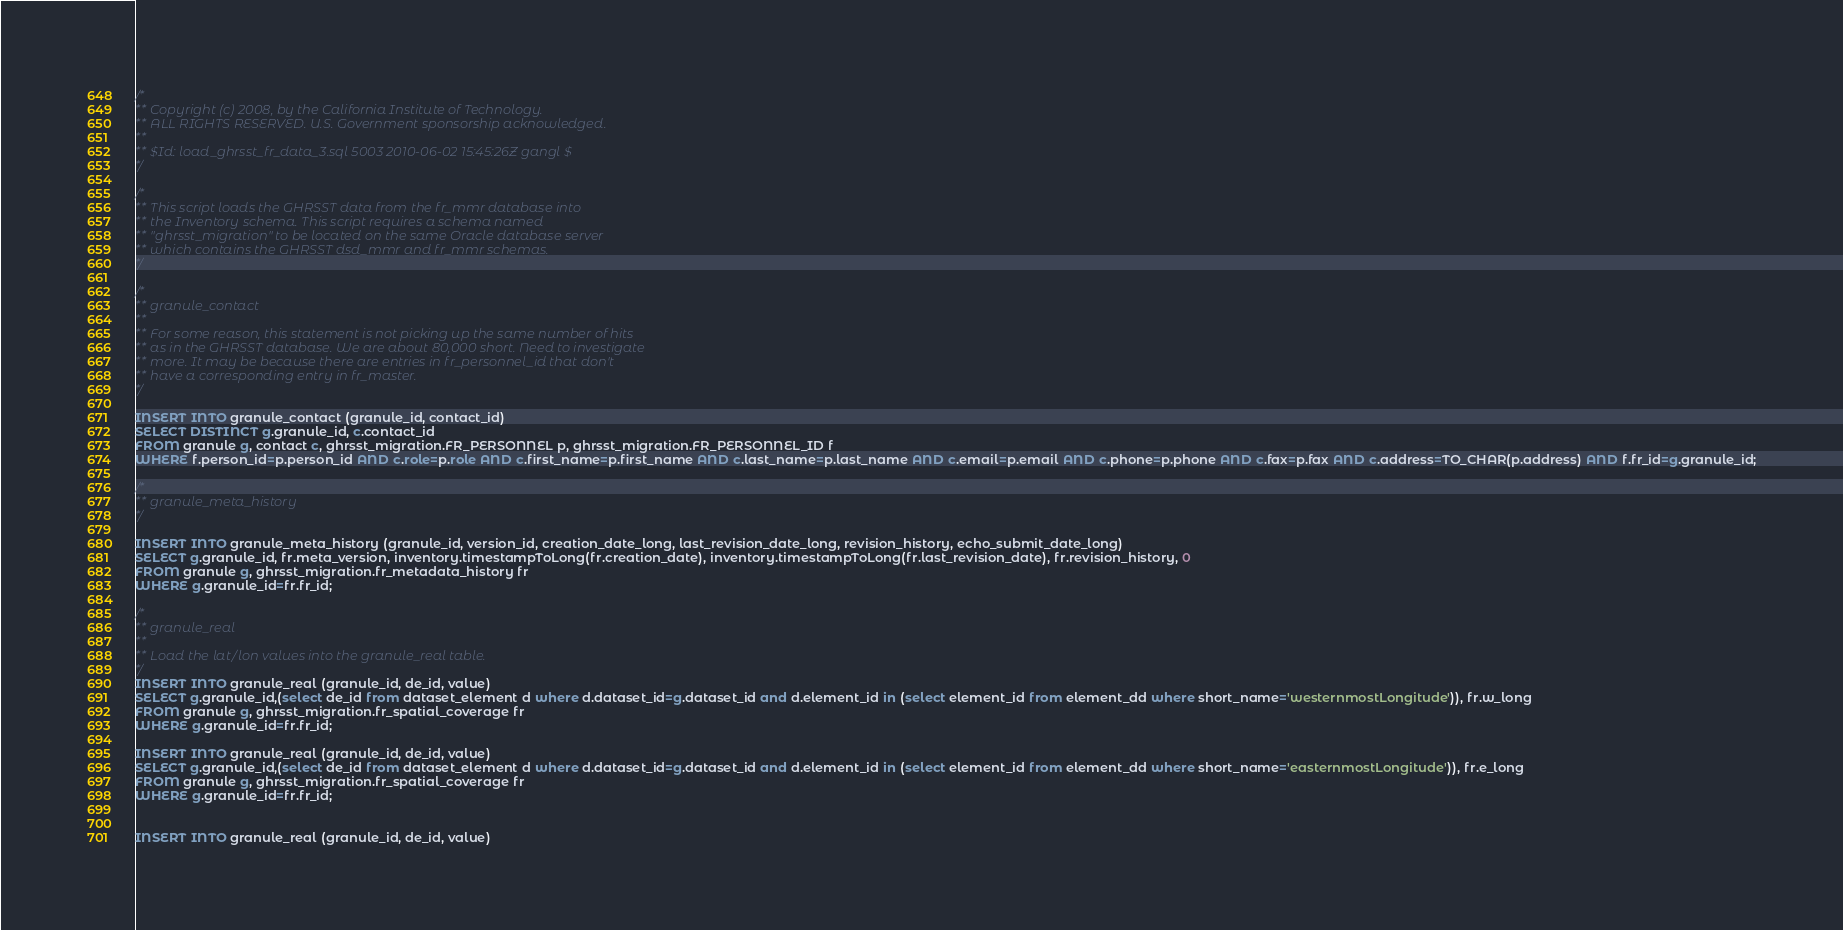<code> <loc_0><loc_0><loc_500><loc_500><_SQL_>/*
** Copyright (c) 2008, by the California Institute of Technology.
** ALL RIGHTS RESERVED. U.S. Government sponsorship acknowledged.
**
** $Id: load_ghrsst_fr_data_3.sql 5003 2010-06-02 15:45:26Z gangl $
*/

/*
** This script loads the GHRSST data from the fr_mmr database into 
** the Inventory schema. This script requires a schema named 
** "ghrsst_migration" to be located on the same Oracle database server 
** which contains the GHRSST dsd_mmr and fr_mmr schemas.
*/

/*
** granule_contact
**
** For some reason, this statement is not picking up the same number of hits 
** as in the GHRSST database. We are about 80,000 short. Need to investigate
** more. It may be because there are entries in fr_personnel_id that don't 
** have a corresponding entry in fr_master.
*/

INSERT INTO granule_contact (granule_id, contact_id)
SELECT DISTINCT g.granule_id, c.contact_id
FROM granule g, contact c, ghrsst_migration.FR_PERSONNEL p, ghrsst_migration.FR_PERSONNEL_ID f
WHERE f.person_id=p.person_id AND c.role=p.role AND c.first_name=p.first_name AND c.last_name=p.last_name AND c.email=p.email AND c.phone=p.phone AND c.fax=p.fax AND c.address=TO_CHAR(p.address) AND f.fr_id=g.granule_id;

/* 
** granule_meta_history
*/

INSERT INTO granule_meta_history (granule_id, version_id, creation_date_long, last_revision_date_long, revision_history, echo_submit_date_long)
SELECT g.granule_id, fr.meta_version, inventory.timestampToLong(fr.creation_date), inventory.timestampToLong(fr.last_revision_date), fr.revision_history, 0
FROM granule g, ghrsst_migration.fr_metadata_history fr
WHERE g.granule_id=fr.fr_id;

/* 
** granule_real
**
** Load the lat/lon values into the granule_real table.
*/
INSERT INTO granule_real (granule_id, de_id, value)
SELECT g.granule_id,(select de_id from dataset_element d where d.dataset_id=g.dataset_id and d.element_id in (select element_id from element_dd where short_name='westernmostLongitude')), fr.w_long
FROM granule g, ghrsst_migration.fr_spatial_coverage fr
WHERE g.granule_id=fr.fr_id;

INSERT INTO granule_real (granule_id, de_id, value)
SELECT g.granule_id,(select de_id from dataset_element d where d.dataset_id=g.dataset_id and d.element_id in (select element_id from element_dd where short_name='easternmostLongitude')), fr.e_long
FROM granule g, ghrsst_migration.fr_spatial_coverage fr
WHERE g.granule_id=fr.fr_id;


INSERT INTO granule_real (granule_id, de_id, value)</code> 